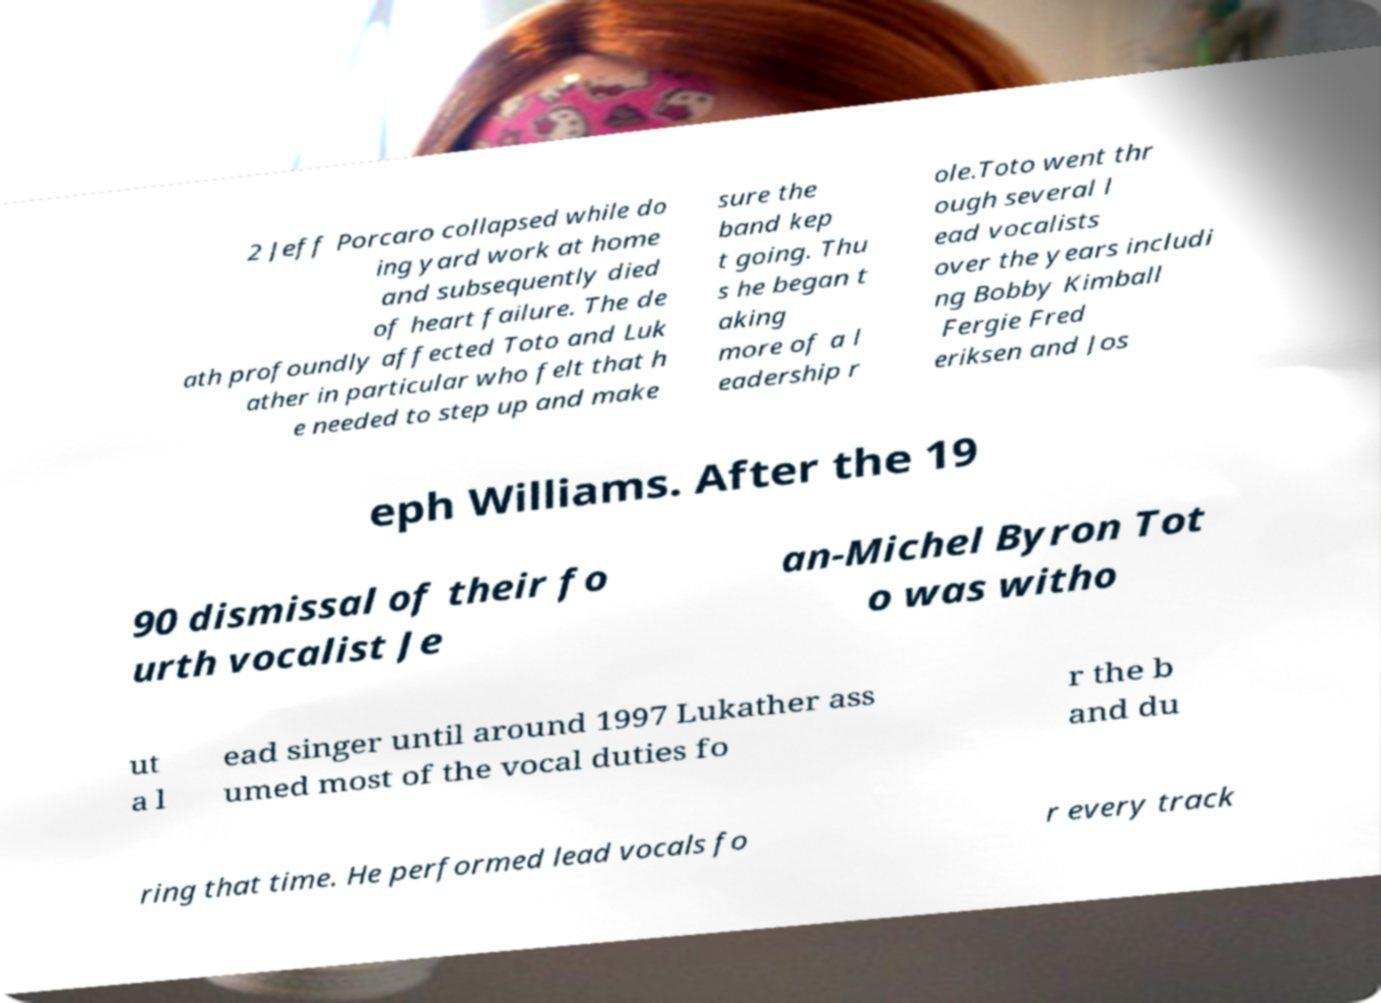I need the written content from this picture converted into text. Can you do that? 2 Jeff Porcaro collapsed while do ing yard work at home and subsequently died of heart failure. The de ath profoundly affected Toto and Luk ather in particular who felt that h e needed to step up and make sure the band kep t going. Thu s he began t aking more of a l eadership r ole.Toto went thr ough several l ead vocalists over the years includi ng Bobby Kimball Fergie Fred eriksen and Jos eph Williams. After the 19 90 dismissal of their fo urth vocalist Je an-Michel Byron Tot o was witho ut a l ead singer until around 1997 Lukather ass umed most of the vocal duties fo r the b and du ring that time. He performed lead vocals fo r every track 